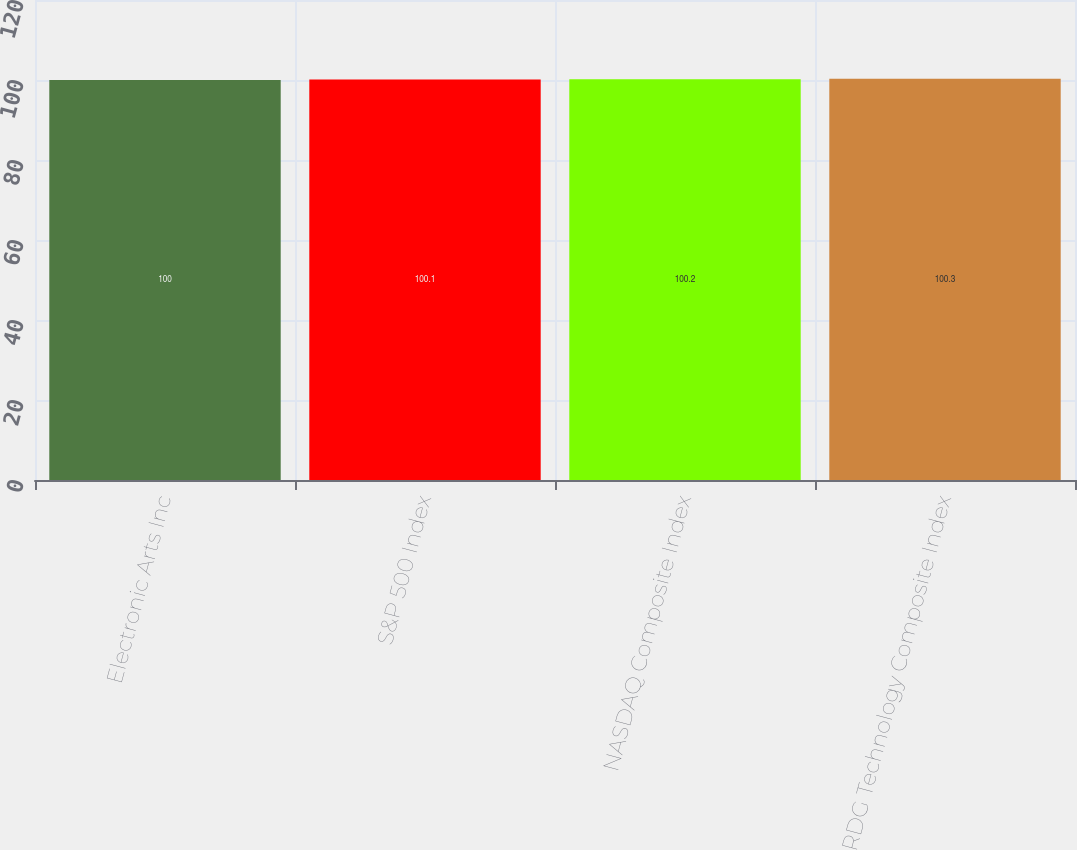<chart> <loc_0><loc_0><loc_500><loc_500><bar_chart><fcel>Electronic Arts Inc<fcel>S&P 500 Index<fcel>NASDAQ Composite Index<fcel>RDG Technology Composite Index<nl><fcel>100<fcel>100.1<fcel>100.2<fcel>100.3<nl></chart> 